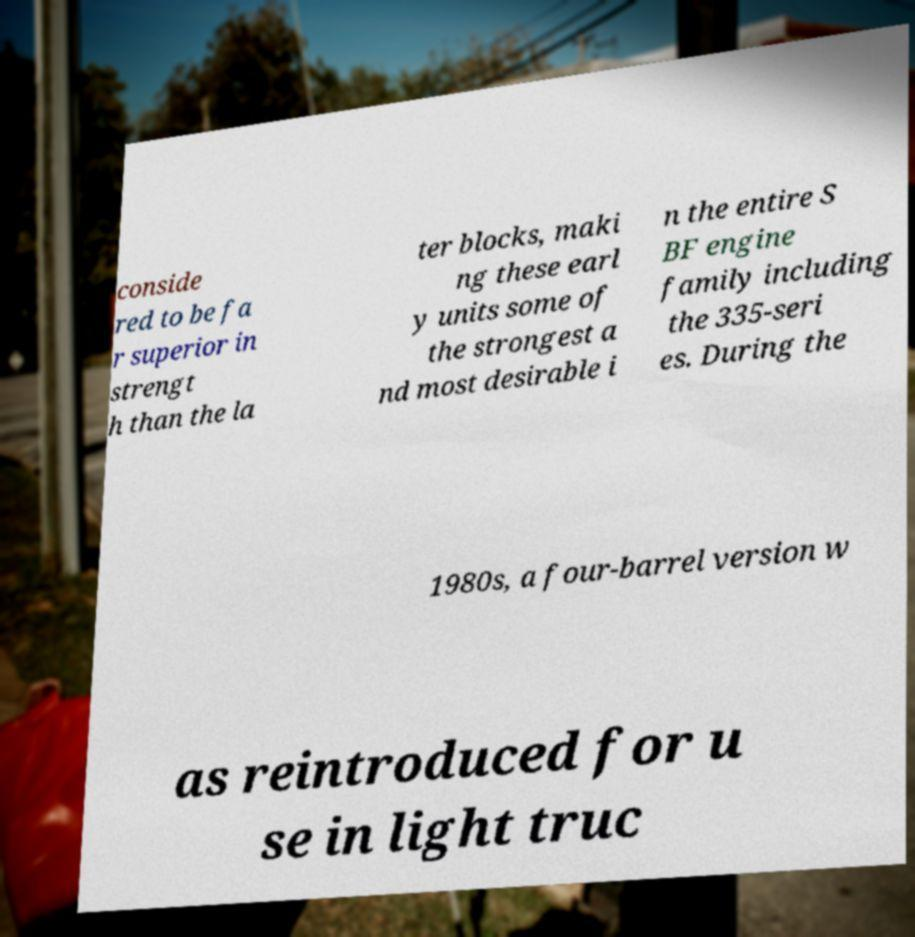Can you read and provide the text displayed in the image?This photo seems to have some interesting text. Can you extract and type it out for me? conside red to be fa r superior in strengt h than the la ter blocks, maki ng these earl y units some of the strongest a nd most desirable i n the entire S BF engine family including the 335-seri es. During the 1980s, a four-barrel version w as reintroduced for u se in light truc 